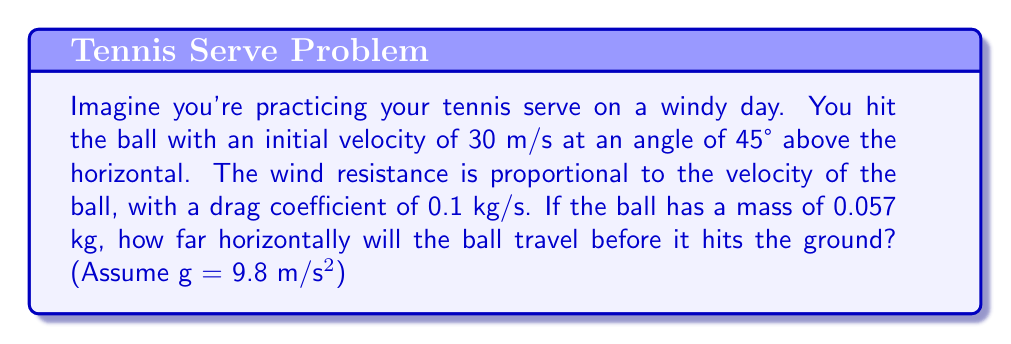Show me your answer to this math problem. Let's approach this step-by-step:

1) First, we need to set up our equations of motion. With air resistance, we have:

   $$\frac{d^2x}{dt^2} = -k\frac{dx}{dt}$$
   $$\frac{d^2y}{dt^2} = -g - k\frac{dy}{dt}$$

   Where $k = 0.1/0.057 = 1.75$ s⁻¹ (drag coefficient divided by mass)

2) The initial conditions are:
   $$v_0 = 30 \text{ m/s}$$
   $$\theta = 45°$$
   $$v_{0x} = v_0 \cos{\theta} = 30 \cos{45°} = 21.21 \text{ m/s}$$
   $$v_{0y} = v_0 \sin{\theta} = 30 \sin{45°} = 21.21 \text{ m/s}$$

3) The solutions to these differential equations are:

   $$x(t) = \frac{v_{0x}}{k}(1-e^{-kt})$$
   $$y(t) = \frac{g}{k^2}(kt-1+e^{-kt}) + \frac{v_{0y}}{k}(1-e^{-kt})$$

4) To find when the ball hits the ground, we need to solve $y(t) = 0$:

   $$\frac{g}{k^2}(kt-1+e^{-kt}) + \frac{v_{0y}}{k}(1-e^{-kt}) = 0$$

5) This equation can't be solved analytically, so we need to use numerical methods. Using a computer or graphing calculator, we find that $t ≈ 2.76$ seconds.

6) Now we can plug this time back into the equation for $x(t)$:

   $$x(2.76) = \frac{21.21}{1.75}(1-e^{-1.75(2.76)}) ≈ 11.95 \text{ m}$$

Therefore, the ball will travel approximately 11.95 meters horizontally before hitting the ground.
Answer: 11.95 m 